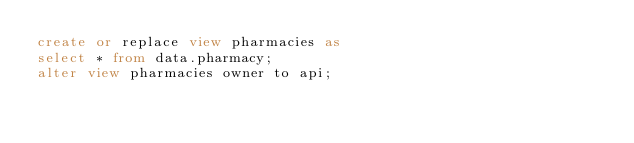<code> <loc_0><loc_0><loc_500><loc_500><_SQL_>create or replace view pharmacies as
select * from data.pharmacy;
alter view pharmacies owner to api;
</code> 